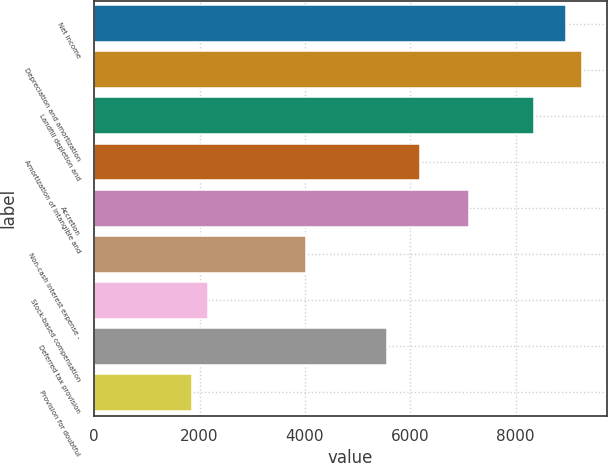<chart> <loc_0><loc_0><loc_500><loc_500><bar_chart><fcel>Net income<fcel>Depreciation and amortization<fcel>Landfill depletion and<fcel>Amortization of intangible and<fcel>Accretion<fcel>Non-cash interest expense -<fcel>Stock-based compensation<fcel>Deferred tax provision<fcel>Provision for doubtful<nl><fcel>8960.73<fcel>9269.7<fcel>8342.79<fcel>6180<fcel>7106.91<fcel>4017.21<fcel>2163.39<fcel>5562.06<fcel>1854.42<nl></chart> 